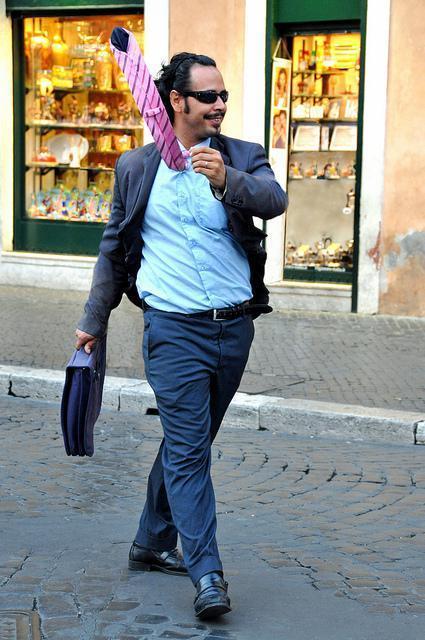How many dogs have a frisbee in their mouth?
Give a very brief answer. 0. 